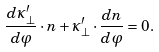<formula> <loc_0><loc_0><loc_500><loc_500>\frac { d \kappa ^ { \prime } _ { \perp } } { d \varphi } \cdot n + \kappa ^ { \prime } _ { \perp } \cdot \frac { d n } { d \varphi } = 0 .</formula> 